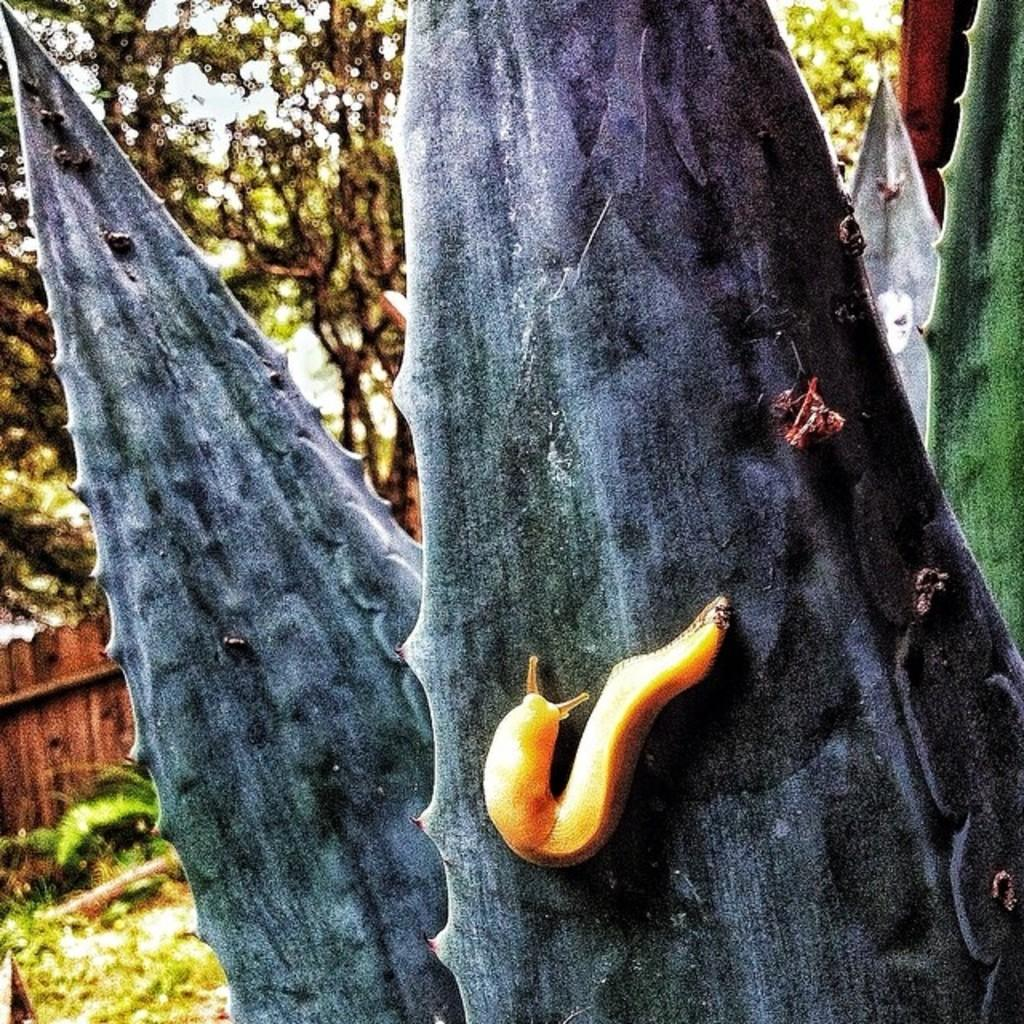What animal can be seen on a plant in the image? There is a snail on a plant in the image. What type of vegetation is visible in the background of the image? There is a group of trees in the background of the image. What type of barrier can be seen in the background of the image? There is a wooden fence in the background of the image. What scientific experiment is being conducted in the image? There is no scientific experiment visible in the image; it features a snail on a plant, trees, and a wooden fence. What type of teeth can be seen on the snail in the image? Snails do not have teeth like mammals; they have a radula, which is a ribbon-like structure with rows of microscopic teeth-like projections. However, there are no visible teeth or radula on the snail in the image. 